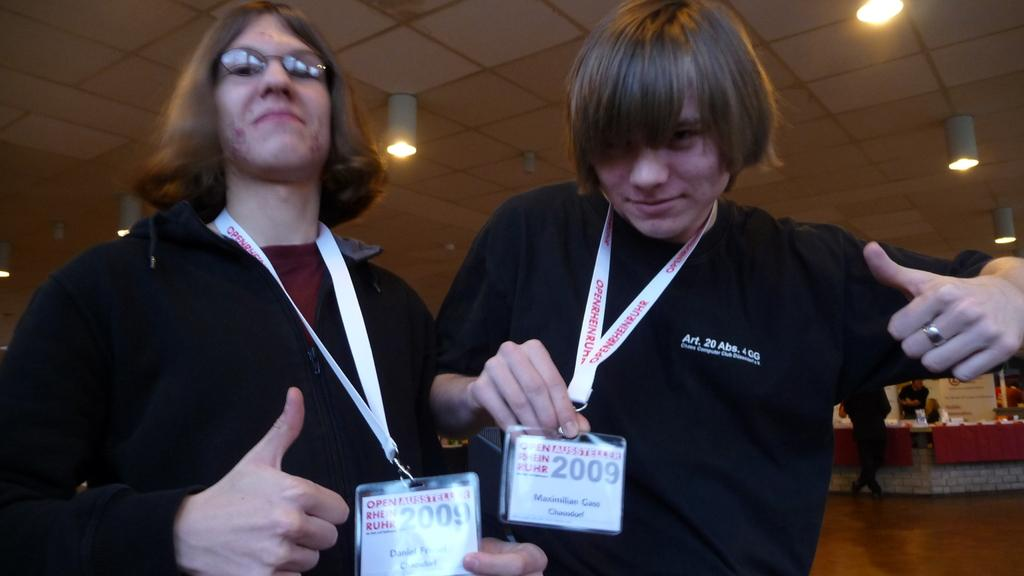How many people are standing in the front of the image? There are 2 people standing in the front of the image. What are the people wearing? The people are wearing black t-shirts. What can be seen on the people's chests? The people have ID cards. What is visible at the top of the image? There are lights at the top of the image. Can you describe the background of the image? There are other people visible in the background of the image. What type of shame is being discussed by the people in the image? There is no indication in the image that the people are discussing shame or any other topic. 